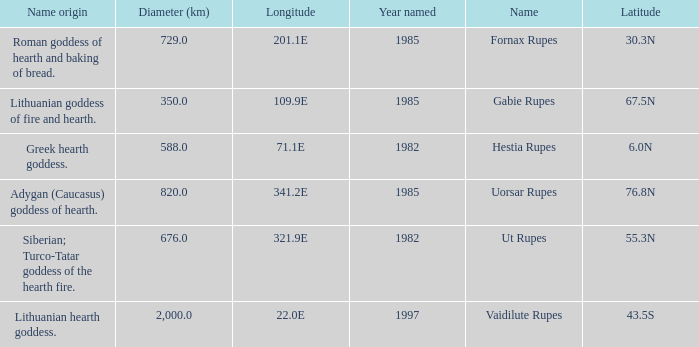What is the latitude of vaidilute rupes? 43.5S. 